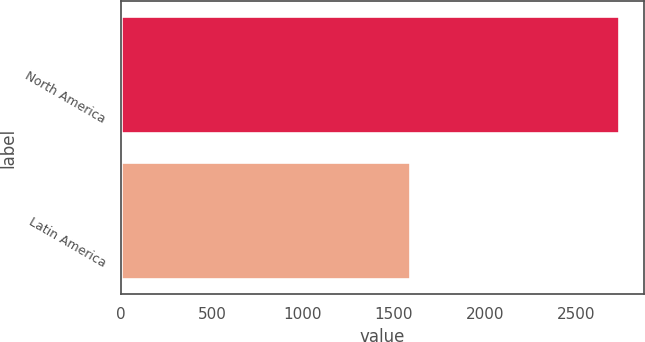Convert chart to OTSL. <chart><loc_0><loc_0><loc_500><loc_500><bar_chart><fcel>North America<fcel>Latin America<nl><fcel>2735<fcel>1589<nl></chart> 